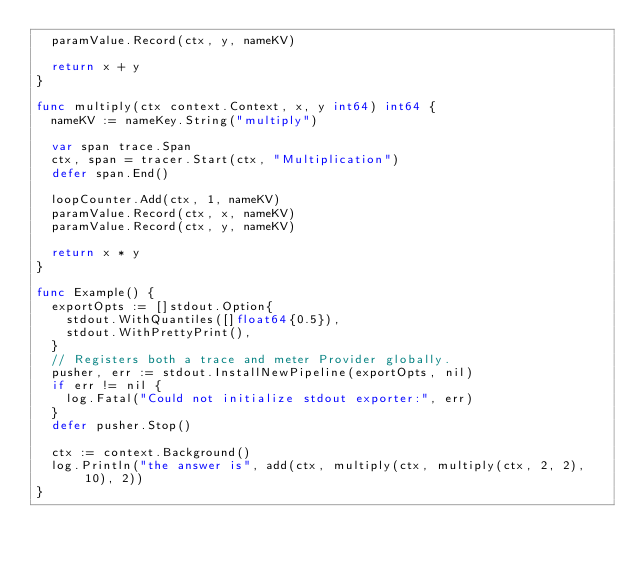Convert code to text. <code><loc_0><loc_0><loc_500><loc_500><_Go_>	paramValue.Record(ctx, y, nameKV)

	return x + y
}

func multiply(ctx context.Context, x, y int64) int64 {
	nameKV := nameKey.String("multiply")

	var span trace.Span
	ctx, span = tracer.Start(ctx, "Multiplication")
	defer span.End()

	loopCounter.Add(ctx, 1, nameKV)
	paramValue.Record(ctx, x, nameKV)
	paramValue.Record(ctx, y, nameKV)

	return x * y
}

func Example() {
	exportOpts := []stdout.Option{
		stdout.WithQuantiles([]float64{0.5}),
		stdout.WithPrettyPrint(),
	}
	// Registers both a trace and meter Provider globally.
	pusher, err := stdout.InstallNewPipeline(exportOpts, nil)
	if err != nil {
		log.Fatal("Could not initialize stdout exporter:", err)
	}
	defer pusher.Stop()

	ctx := context.Background()
	log.Println("the answer is", add(ctx, multiply(ctx, multiply(ctx, 2, 2), 10), 2))
}
</code> 